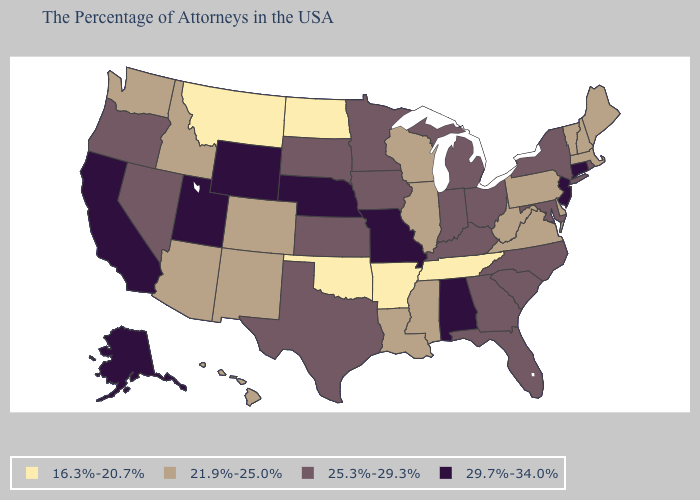Among the states that border Kansas , does Missouri have the lowest value?
Concise answer only. No. Among the states that border Delaware , does Maryland have the highest value?
Give a very brief answer. No. What is the value of Virginia?
Answer briefly. 21.9%-25.0%. What is the highest value in the Northeast ?
Be succinct. 29.7%-34.0%. Name the states that have a value in the range 25.3%-29.3%?
Short answer required. Rhode Island, New York, Maryland, North Carolina, South Carolina, Ohio, Florida, Georgia, Michigan, Kentucky, Indiana, Minnesota, Iowa, Kansas, Texas, South Dakota, Nevada, Oregon. Name the states that have a value in the range 21.9%-25.0%?
Write a very short answer. Maine, Massachusetts, New Hampshire, Vermont, Delaware, Pennsylvania, Virginia, West Virginia, Wisconsin, Illinois, Mississippi, Louisiana, Colorado, New Mexico, Arizona, Idaho, Washington, Hawaii. What is the value of Indiana?
Write a very short answer. 25.3%-29.3%. What is the value of Massachusetts?
Short answer required. 21.9%-25.0%. Name the states that have a value in the range 29.7%-34.0%?
Be succinct. Connecticut, New Jersey, Alabama, Missouri, Nebraska, Wyoming, Utah, California, Alaska. What is the highest value in the USA?
Quick response, please. 29.7%-34.0%. What is the value of Minnesota?
Keep it brief. 25.3%-29.3%. Name the states that have a value in the range 25.3%-29.3%?
Give a very brief answer. Rhode Island, New York, Maryland, North Carolina, South Carolina, Ohio, Florida, Georgia, Michigan, Kentucky, Indiana, Minnesota, Iowa, Kansas, Texas, South Dakota, Nevada, Oregon. Is the legend a continuous bar?
Concise answer only. No. What is the value of Utah?
Quick response, please. 29.7%-34.0%. 